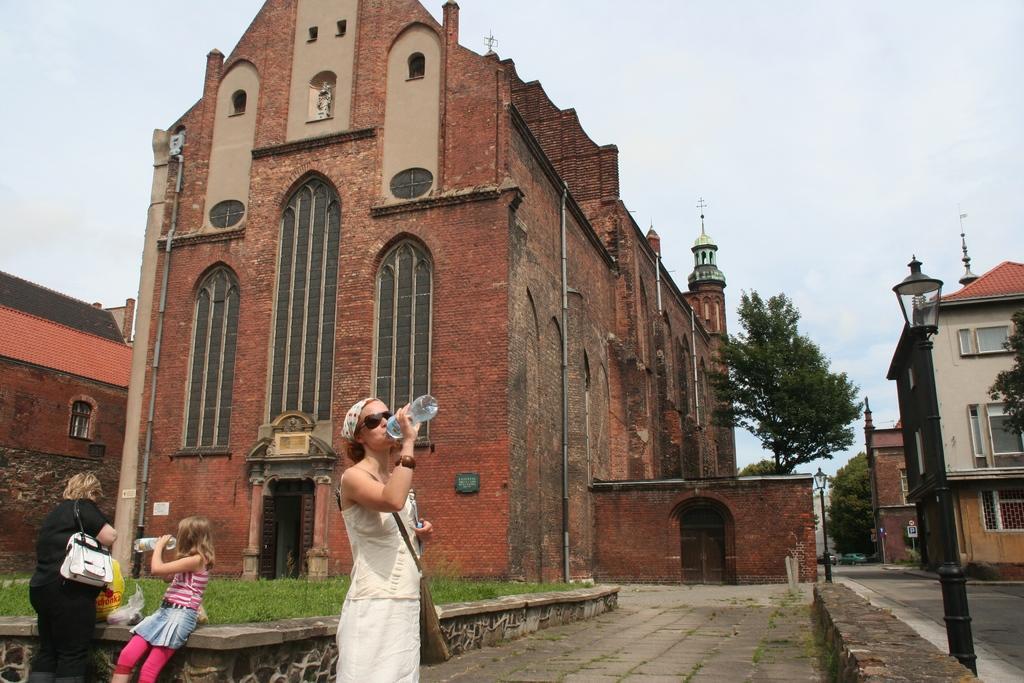Could you give a brief overview of what you see in this image? In this picture we can see there are three persons. Behind the people, there is grass and buildings. On the right side of the image there are trees, some vehicles on the road and there are poles with lights. Behind the buildings, there is the sky. 